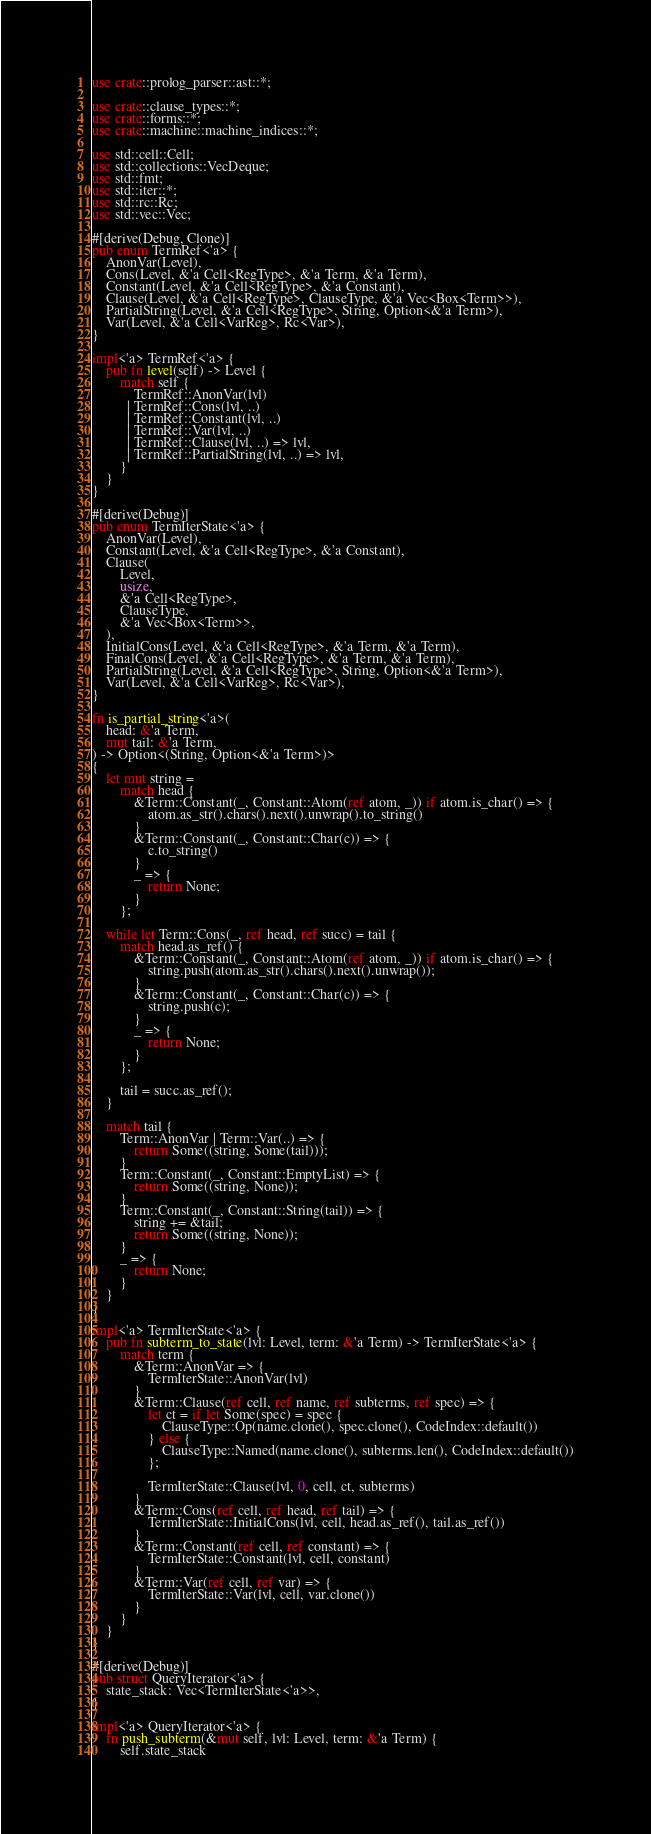<code> <loc_0><loc_0><loc_500><loc_500><_Rust_>use crate::prolog_parser::ast::*;

use crate::clause_types::*;
use crate::forms::*;
use crate::machine::machine_indices::*;

use std::cell::Cell;
use std::collections::VecDeque;
use std::fmt;
use std::iter::*;
use std::rc::Rc;
use std::vec::Vec;

#[derive(Debug, Clone)]
pub enum TermRef<'a> {
    AnonVar(Level),
    Cons(Level, &'a Cell<RegType>, &'a Term, &'a Term),
    Constant(Level, &'a Cell<RegType>, &'a Constant),
    Clause(Level, &'a Cell<RegType>, ClauseType, &'a Vec<Box<Term>>),
    PartialString(Level, &'a Cell<RegType>, String, Option<&'a Term>),
    Var(Level, &'a Cell<VarReg>, Rc<Var>),
}

impl<'a> TermRef<'a> {
    pub fn level(self) -> Level {
        match self {
            TermRef::AnonVar(lvl)
          | TermRef::Cons(lvl, ..)
          | TermRef::Constant(lvl, ..)
          | TermRef::Var(lvl, ..)
          | TermRef::Clause(lvl, ..) => lvl,
          | TermRef::PartialString(lvl, ..) => lvl,
        }
    }
}

#[derive(Debug)]
pub enum TermIterState<'a> {
    AnonVar(Level),
    Constant(Level, &'a Cell<RegType>, &'a Constant),
    Clause(
        Level,
        usize,
        &'a Cell<RegType>,
        ClauseType,
        &'a Vec<Box<Term>>,
    ),
    InitialCons(Level, &'a Cell<RegType>, &'a Term, &'a Term),
    FinalCons(Level, &'a Cell<RegType>, &'a Term, &'a Term),
    PartialString(Level, &'a Cell<RegType>, String, Option<&'a Term>),
    Var(Level, &'a Cell<VarReg>, Rc<Var>),
}

fn is_partial_string<'a>(
    head: &'a Term,
    mut tail: &'a Term,
) -> Option<(String, Option<&'a Term>)>
{
    let mut string =
        match head {
            &Term::Constant(_, Constant::Atom(ref atom, _)) if atom.is_char() => {
                atom.as_str().chars().next().unwrap().to_string()
            }
            &Term::Constant(_, Constant::Char(c)) => {
                c.to_string()
            }
            _ => {
                return None;
            }
        };

    while let Term::Cons(_, ref head, ref succ) = tail {
        match head.as_ref() {
            &Term::Constant(_, Constant::Atom(ref atom, _)) if atom.is_char() => {
                string.push(atom.as_str().chars().next().unwrap());
            }
            &Term::Constant(_, Constant::Char(c)) => {
                string.push(c);
            }
            _ => {
                return None;
            }
        };

        tail = succ.as_ref();
    }

    match tail {
        Term::AnonVar | Term::Var(..) => {
            return Some((string, Some(tail)));
        }
        Term::Constant(_, Constant::EmptyList) => {
            return Some((string, None));
        }
        Term::Constant(_, Constant::String(tail)) => {
            string += &tail;
            return Some((string, None));
        }
        _ => {
            return None;
        }
    }
}

impl<'a> TermIterState<'a> {
    pub fn subterm_to_state(lvl: Level, term: &'a Term) -> TermIterState<'a> {
        match term {
            &Term::AnonVar => {
                TermIterState::AnonVar(lvl)
            }
            &Term::Clause(ref cell, ref name, ref subterms, ref spec) => {
                let ct = if let Some(spec) = spec {
                    ClauseType::Op(name.clone(), spec.clone(), CodeIndex::default())
                } else {
                    ClauseType::Named(name.clone(), subterms.len(), CodeIndex::default())
                };

                TermIterState::Clause(lvl, 0, cell, ct, subterms)
            }
            &Term::Cons(ref cell, ref head, ref tail) => {
                TermIterState::InitialCons(lvl, cell, head.as_ref(), tail.as_ref())
            }
            &Term::Constant(ref cell, ref constant) => {
                TermIterState::Constant(lvl, cell, constant)
            }
            &Term::Var(ref cell, ref var) => {
                TermIterState::Var(lvl, cell, var.clone())
            }
        }
    }
}

#[derive(Debug)]
pub struct QueryIterator<'a> {
    state_stack: Vec<TermIterState<'a>>,
}

impl<'a> QueryIterator<'a> {
    fn push_subterm(&mut self, lvl: Level, term: &'a Term) {
        self.state_stack</code> 